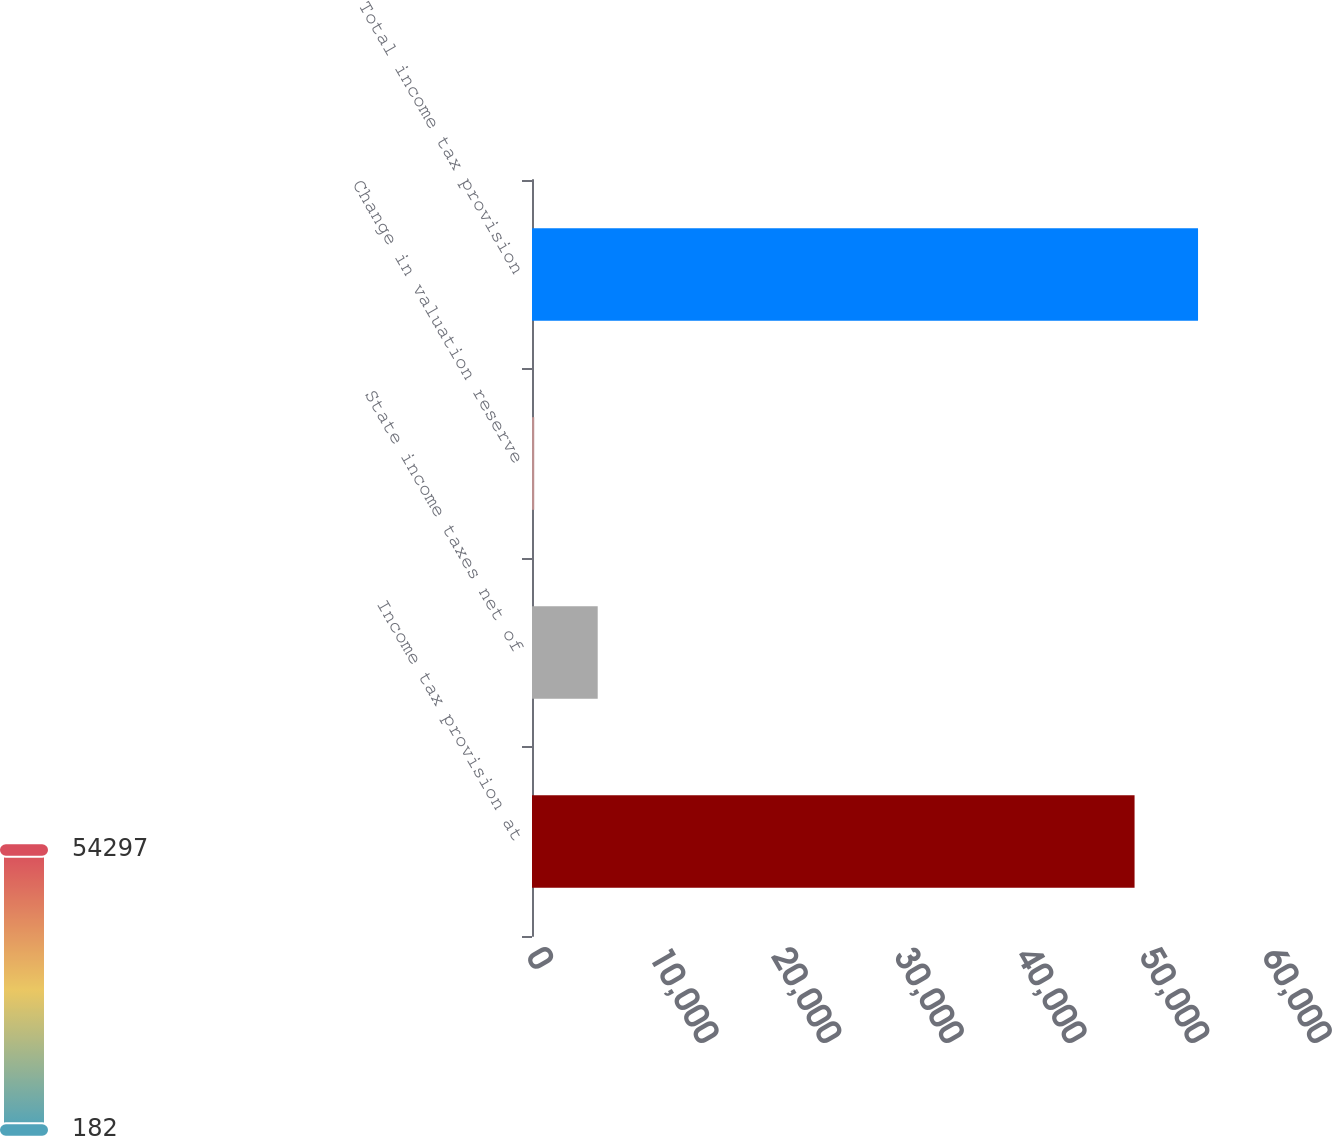<chart> <loc_0><loc_0><loc_500><loc_500><bar_chart><fcel>Income tax provision at<fcel>State income taxes net of<fcel>Change in valuation reserve<fcel>Total income tax provision<nl><fcel>49122<fcel>5356.8<fcel>182<fcel>54296.8<nl></chart> 